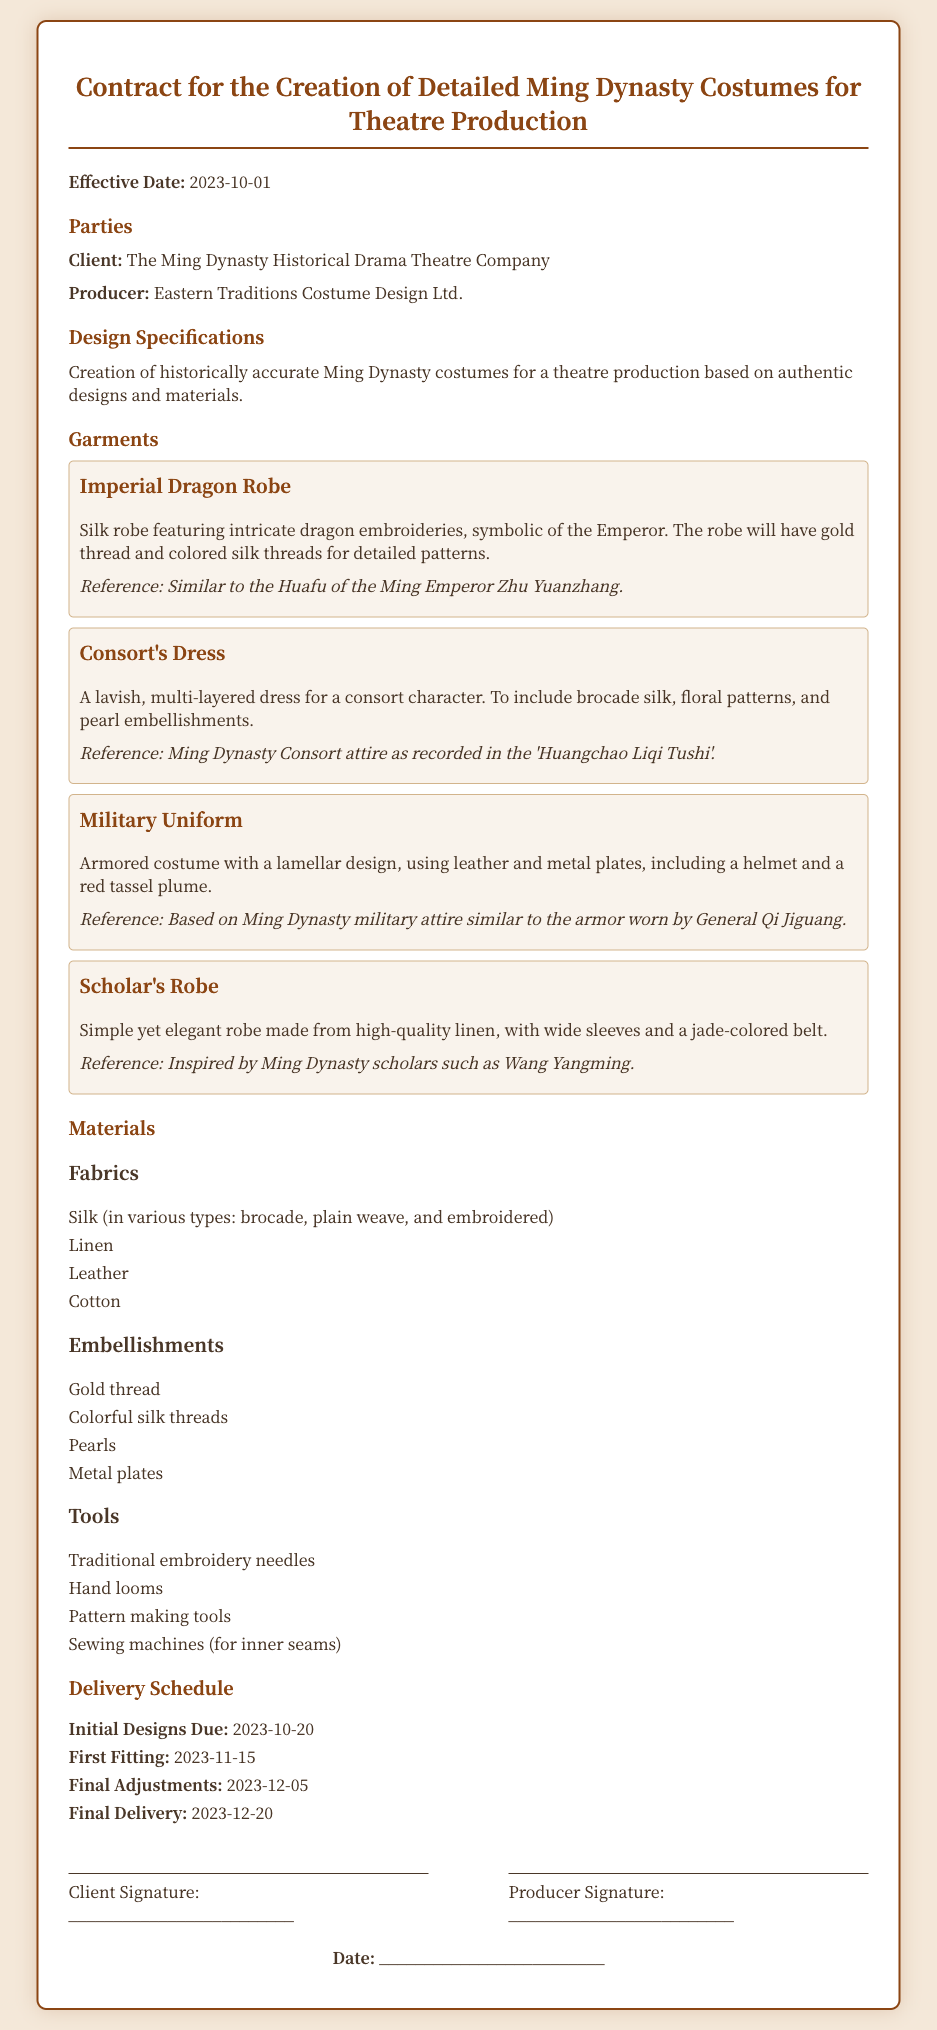What is the effective date of the contract? The effective date is specified at the beginning of the contract document.
Answer: 2023-10-01 Who is the client in this contract? The contract specifies the name of the client under the "Client" section.
Answer: The Ming Dynasty Historical Drama Theatre Company What is the title of the first garment listed? The first garment is clearly listed in the "Garments" section of the document.
Answer: Imperial Dragon Robe When is the final delivery date scheduled? The schedule for delivery is outlined in the "Delivery Schedule" section of the document.
Answer: 2023-12-20 What material is used for the Scholar's Robe? The material used for each garment is detailed in its description in the document.
Answer: High-quality linen How many types of fabrics are listed? The document enumerates the types of fabrics under the "Fabrics" heading.
Answer: Four What embellishment is mentioned for the Consort's Dress? The specific embellishments for each garment are outlined in their descriptions.
Answer: Pearl embellishments What is the date for the first fitting? The date for various important events is listed in the "Delivery Schedule."
Answer: 2023-11-15 How many parties are involved in this contract? The parties involved are identified in the "Parties" section of the document.
Answer: Two 